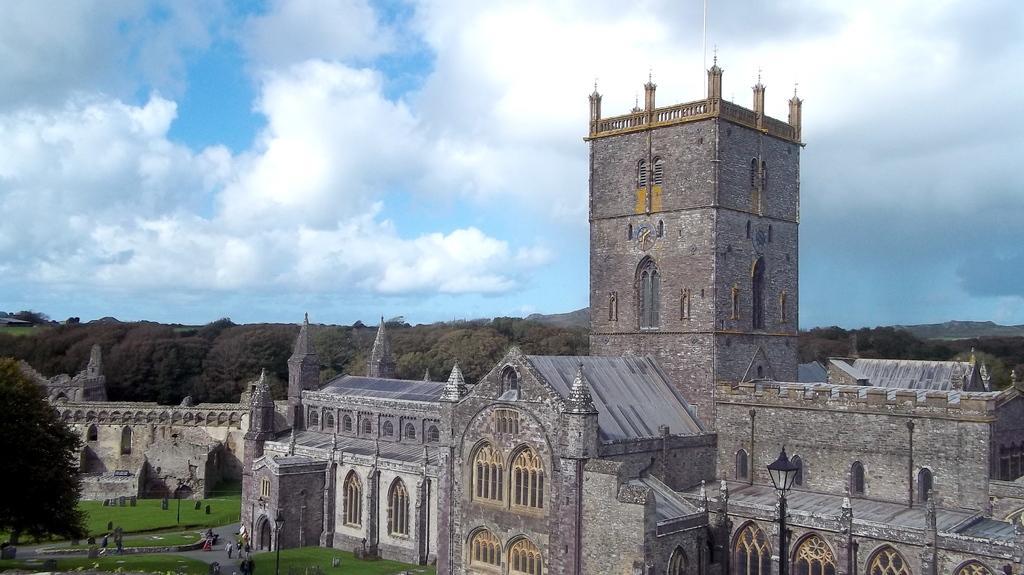Describe this image in one or two sentences. There is a stone castle in the center of the image and there are people, tombstones and grassland at the bottom side. There are trees and sky in the background area. 